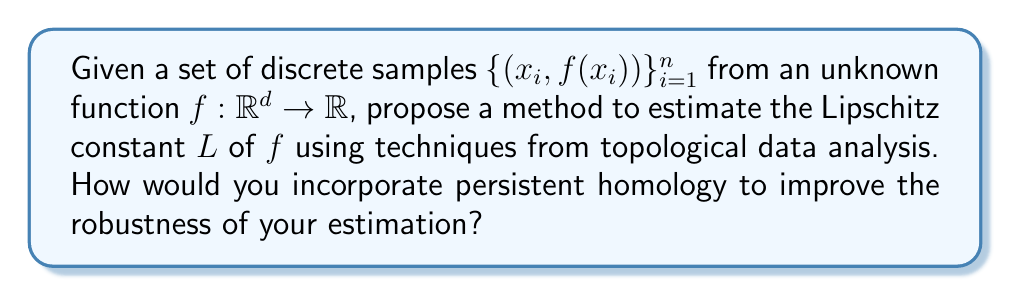Can you answer this question? To estimate the Lipschitz constant $L$ of a function $f$ using discrete samples and techniques from topological data analysis, we can follow these steps:

1. Construct a simplicial complex:
   Create a Vietoris-Rips complex $VR_\epsilon(X)$ from the input points $X = \{x_i\}_{i=1}^n$ in the domain space $\mathbb{R}^d$.

2. Define a function on the simplicial complex:
   Extend $f$ to the simplicial complex by linear interpolation on simplices.

3. Compute persistent homology:
   Calculate the persistent homology of the sublevel sets of the extended function on the simplicial complex.

4. Estimate the Lipschitz constant:
   For each pair of points $(x_i, x_j)$ in the sample, compute:
   
   $$L_{ij} = \frac{|f(x_i) - f(x_j)|}{\|x_i - x_j\|}$$

   The estimated Lipschitz constant $\hat{L}$ is the maximum $L_{ij}$ over all pairs:
   
   $$\hat{L} = \max_{i,j} L_{ij}$$

5. Incorporate persistent homology:
   Use the persistence diagram to identify stable topological features and filter out noise. Consider only the $L_{ij}$ values corresponding to edges in the simplicial complex that persist for a significant range of $\epsilon$ values in the filtration.

6. Refine the estimate:
   Compute a weighted average of the $L_{ij}$ values, with weights based on the persistence of the corresponding edges in the filtration. This gives a more robust estimate $\hat{L}_w$:

   $$\hat{L}_w = \frac{\sum_{i,j} w_{ij} L_{ij}}{\sum_{i,j} w_{ij}}$$

   where $w_{ij}$ is the persistence of the edge connecting $x_i$ and $x_j$ in the filtration.

This method leverages the stability of topological features to provide a more robust estimate of the Lipschitz constant, particularly in the presence of noise or outliers in the sample data.
Answer: The estimated Lipschitz constant $\hat{L}_w$ is given by the weighted average:

$$\hat{L}_w = \frac{\sum_{i,j} w_{ij} L_{ij}}{\sum_{i,j} w_{ij}}$$

where $L_{ij} = \frac{|f(x_i) - f(x_j)|}{\|x_i - x_j\|}$ and $w_{ij}$ is the persistence of the edge connecting $x_i$ and $x_j$ in the Vietoris-Rips complex filtration. 